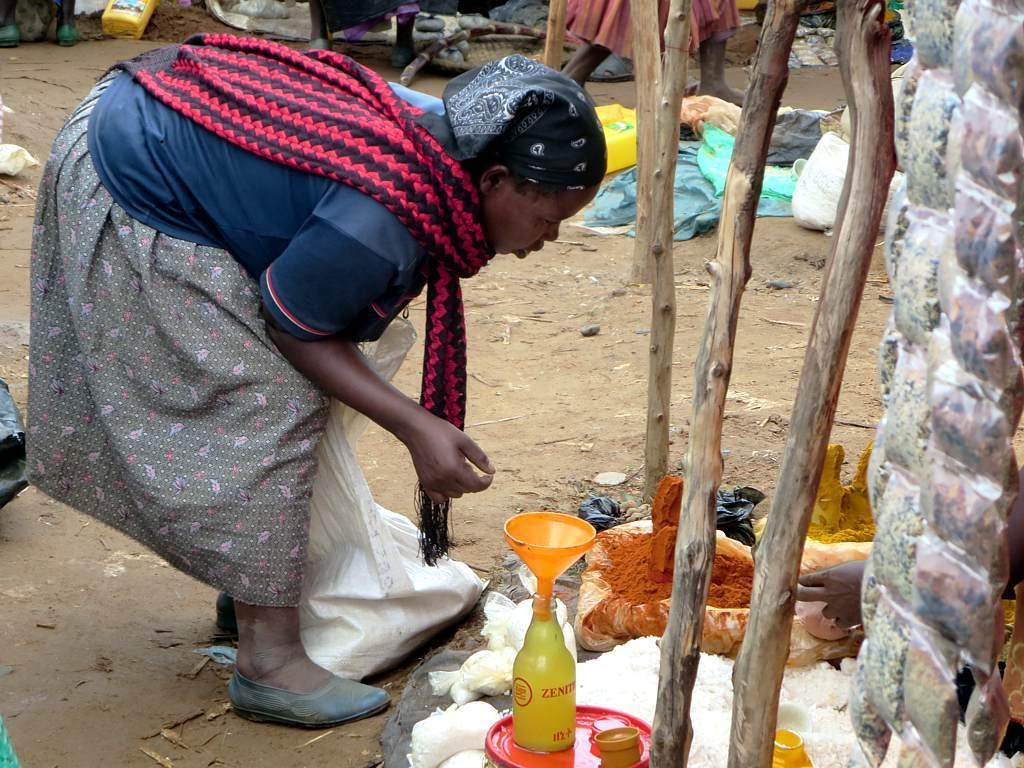What is the woman doing in the image? The woman is on the ground in the image. What can be seen besides the woman in the image? There is a bottle, wooden poles, a funnel, clothes, person's legs, cans, and some unspecified objects in the image. Can you describe the wooden poles in the image? The wooden poles are visible in the image. What might be the purpose of the funnel in the image? The funnel could be used for pouring or transferring liquids in the image. What type of ring can be seen on the woman's finger in the image? There is no ring visible on the woman's finger in the image. What is the woman drinking in the image? The image does not show the woman drinking anything, as there is no reference to a drink or beverage. 